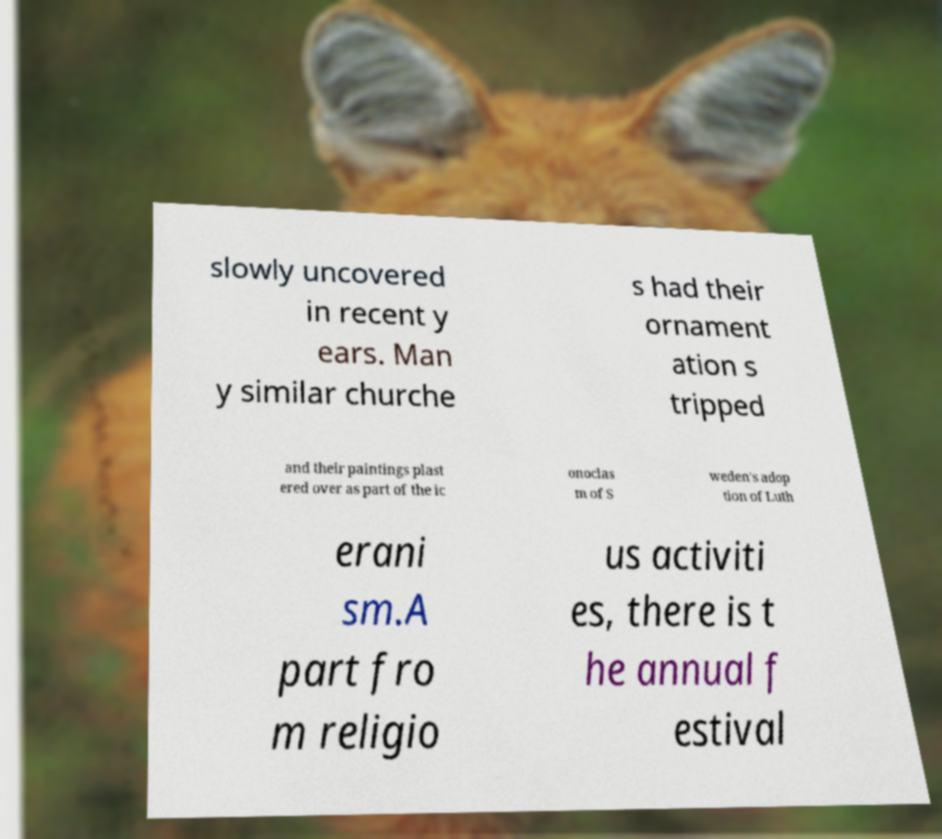Can you accurately transcribe the text from the provided image for me? slowly uncovered in recent y ears. Man y similar churche s had their ornament ation s tripped and their paintings plast ered over as part of the ic onoclas m of S weden's adop tion of Luth erani sm.A part fro m religio us activiti es, there is t he annual f estival 